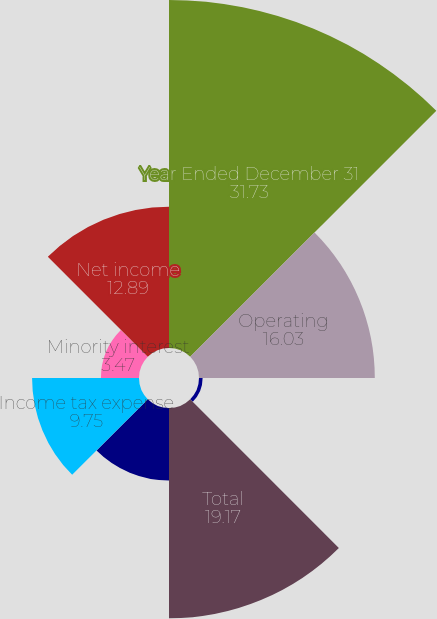<chart> <loc_0><loc_0><loc_500><loc_500><pie_chart><fcel>Year Ended December 31<fcel>Operating<fcel>Net investment income<fcel>Total<fcel>Interest<fcel>Income tax expense<fcel>Minority interest<fcel>Net income<nl><fcel>31.73%<fcel>16.03%<fcel>0.33%<fcel>19.17%<fcel>6.61%<fcel>9.75%<fcel>3.47%<fcel>12.89%<nl></chart> 